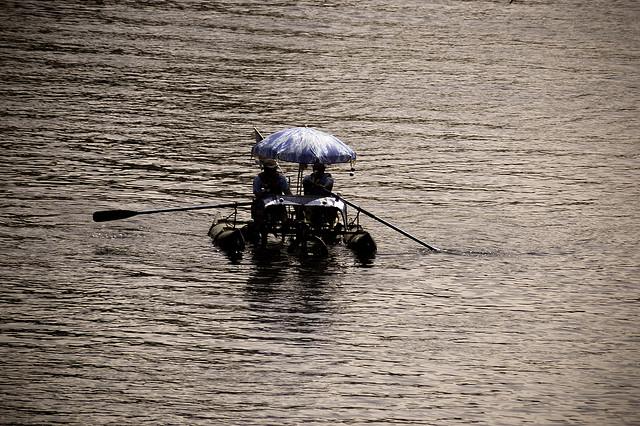How many boats?
Keep it brief. 1. How many people are on the boat?
Concise answer only. 2. How many oars are being used?
Quick response, please. 2. 